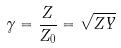Convert formula to latex. <formula><loc_0><loc_0><loc_500><loc_500>\gamma = \frac { Z } { Z _ { 0 } } = \sqrt { Z Y }</formula> 